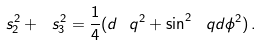Convert formula to latex. <formula><loc_0><loc_0><loc_500><loc_500>\ s _ { 2 } ^ { 2 } + \ s _ { 3 } ^ { 2 } = \frac { 1 } { 4 } ( d \ q ^ { 2 } + \sin ^ { 2 } \ q d \phi ^ { 2 } ) \, .</formula> 